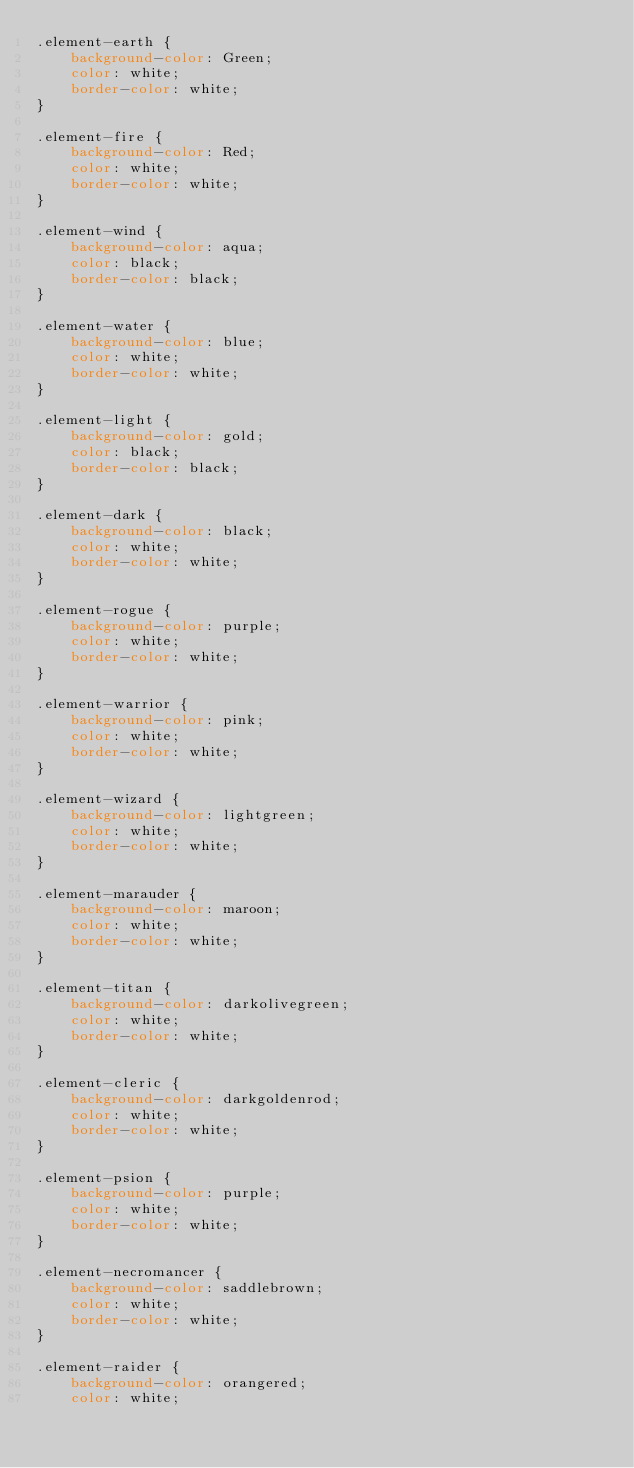<code> <loc_0><loc_0><loc_500><loc_500><_CSS_>.element-earth {
    background-color: Green;
    color: white;
    border-color: white;
}

.element-fire {
    background-color: Red;
    color: white;
    border-color: white;
}

.element-wind {
    background-color: aqua;
    color: black;
    border-color: black;
}

.element-water {
    background-color: blue;
    color: white;
    border-color: white;
}

.element-light {
    background-color: gold;
    color: black;
    border-color: black;
}

.element-dark {
    background-color: black;
    color: white;
    border-color: white;
}

.element-rogue {
    background-color: purple;
    color: white;
    border-color: white;
}

.element-warrior {
    background-color: pink;
    color: white;
    border-color: white;
}

.element-wizard {
    background-color: lightgreen;
    color: white;
    border-color: white;
}

.element-marauder {
    background-color: maroon;
    color: white;
    border-color: white;
}

.element-titan {
    background-color: darkolivegreen;
    color: white;
    border-color: white;
}

.element-cleric {
    background-color: darkgoldenrod;
    color: white;
    border-color: white;
}

.element-psion {
    background-color: purple;
    color: white;
    border-color: white;
}

.element-necromancer {
    background-color: saddlebrown;
    color: white;
    border-color: white;
}

.element-raider {
    background-color: orangered;
    color: white;</code> 